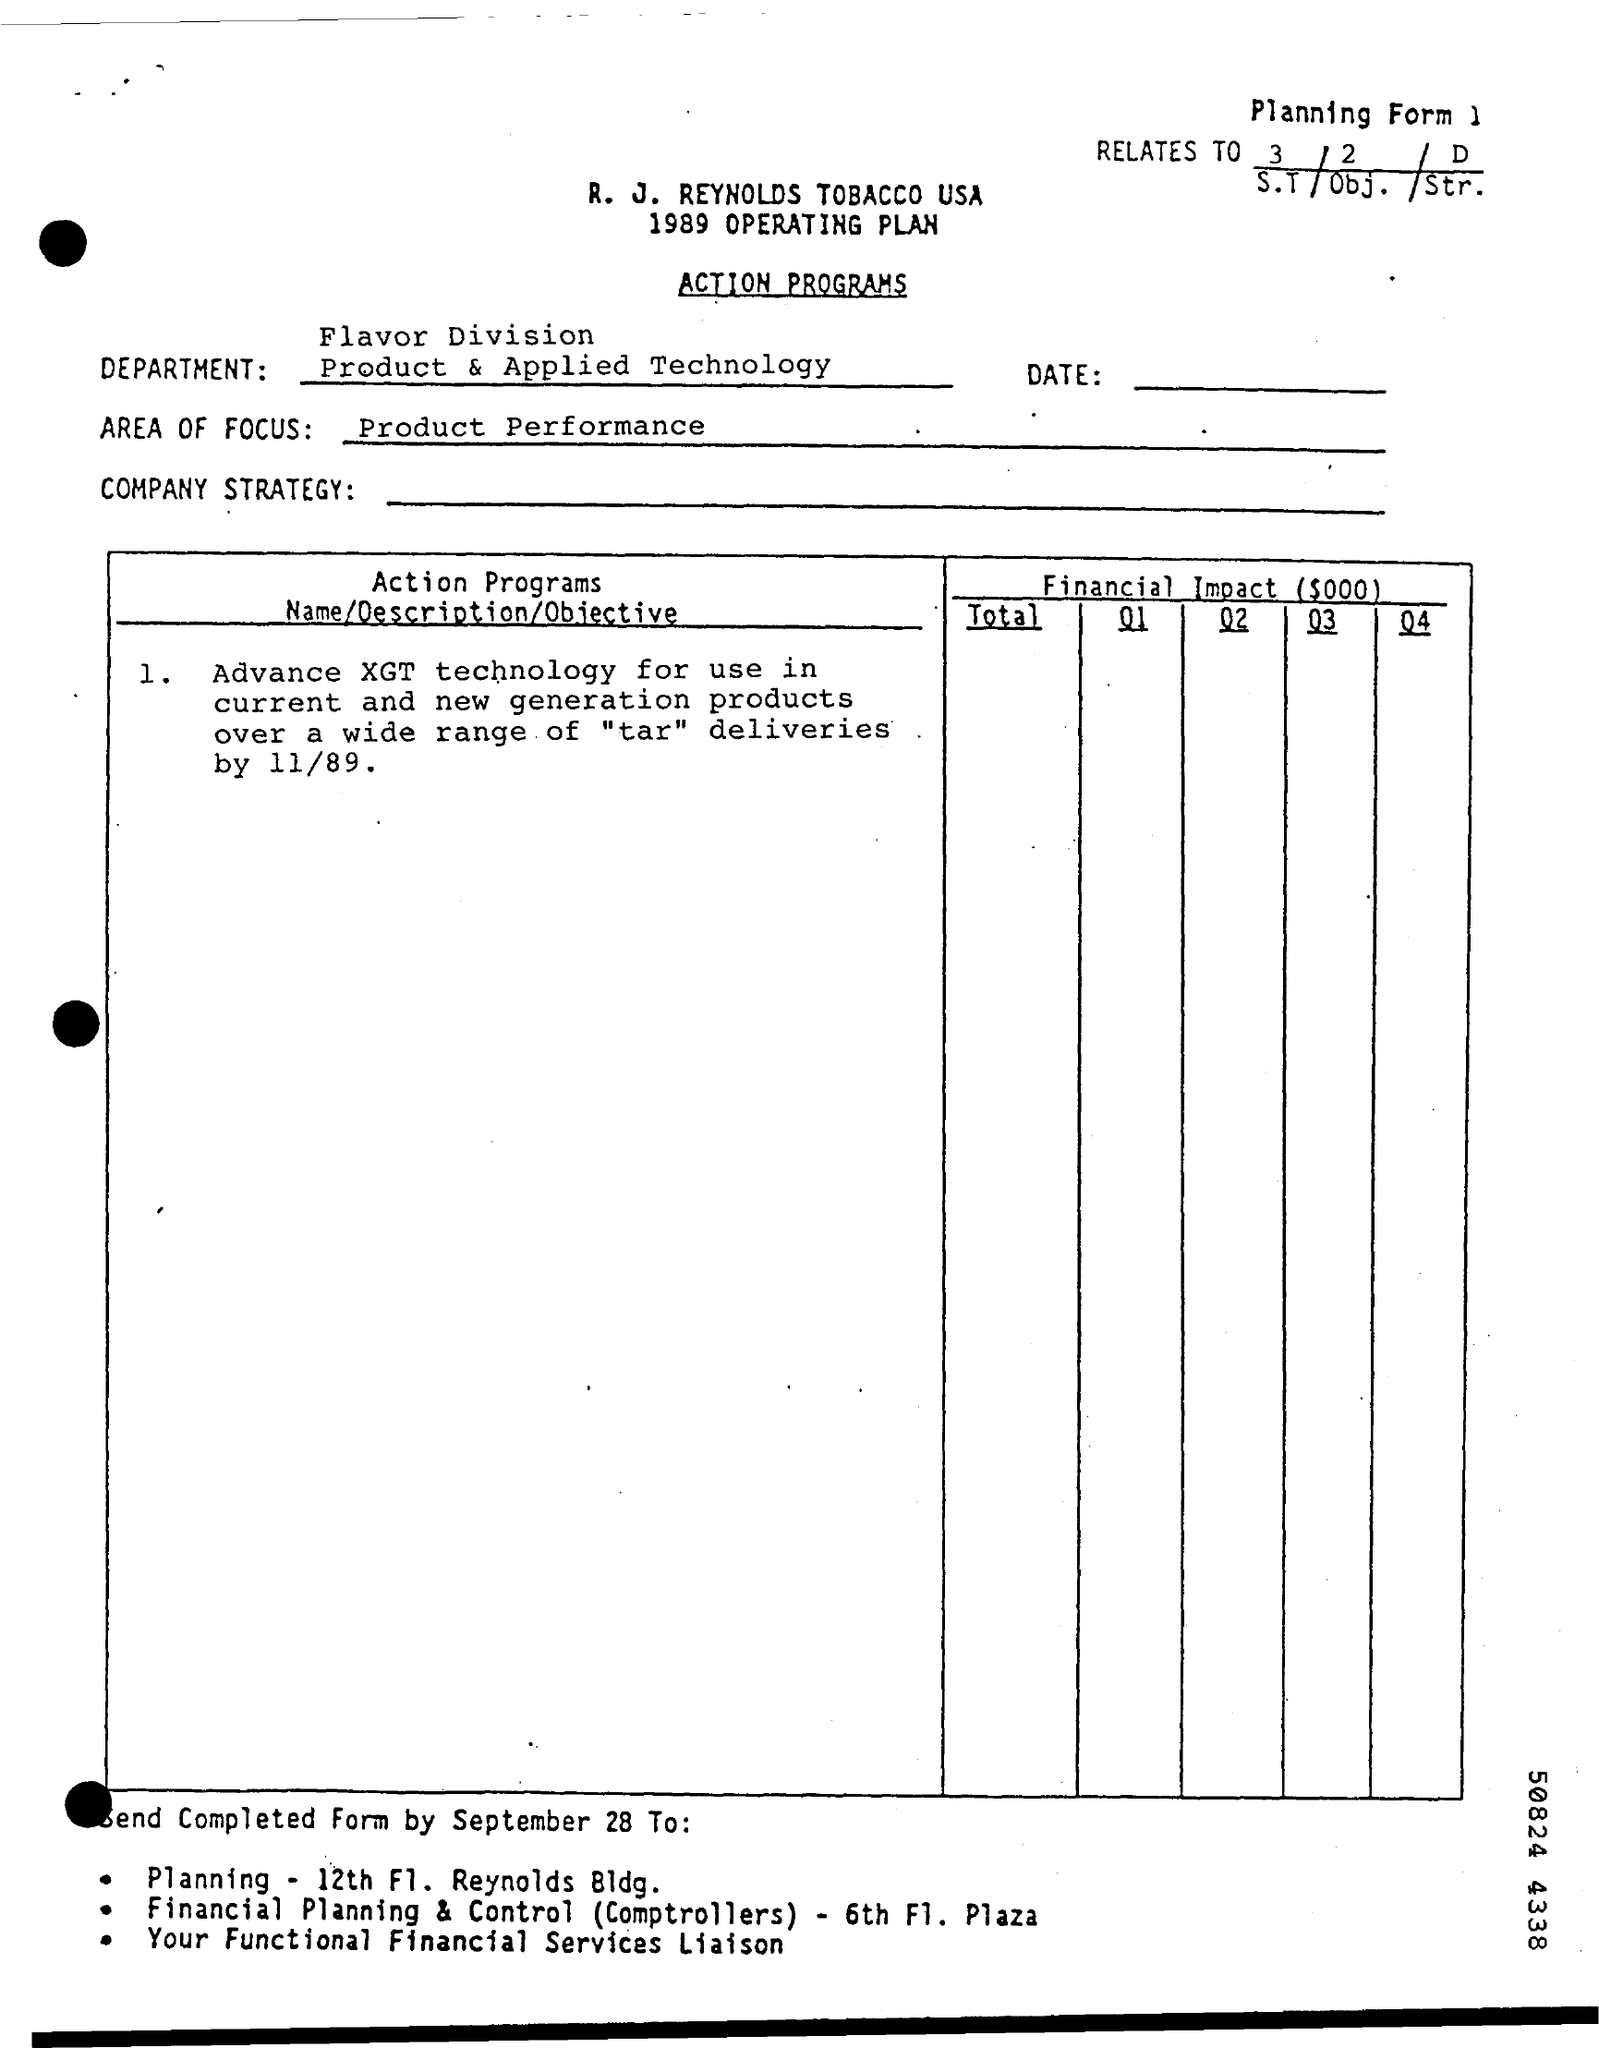What are the AREA OF FOCUS
Provide a short and direct response. Product Performance. 